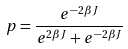<formula> <loc_0><loc_0><loc_500><loc_500>p = \frac { e ^ { - 2 \beta J } } { e ^ { 2 \beta J } + e ^ { - 2 \beta J } }</formula> 